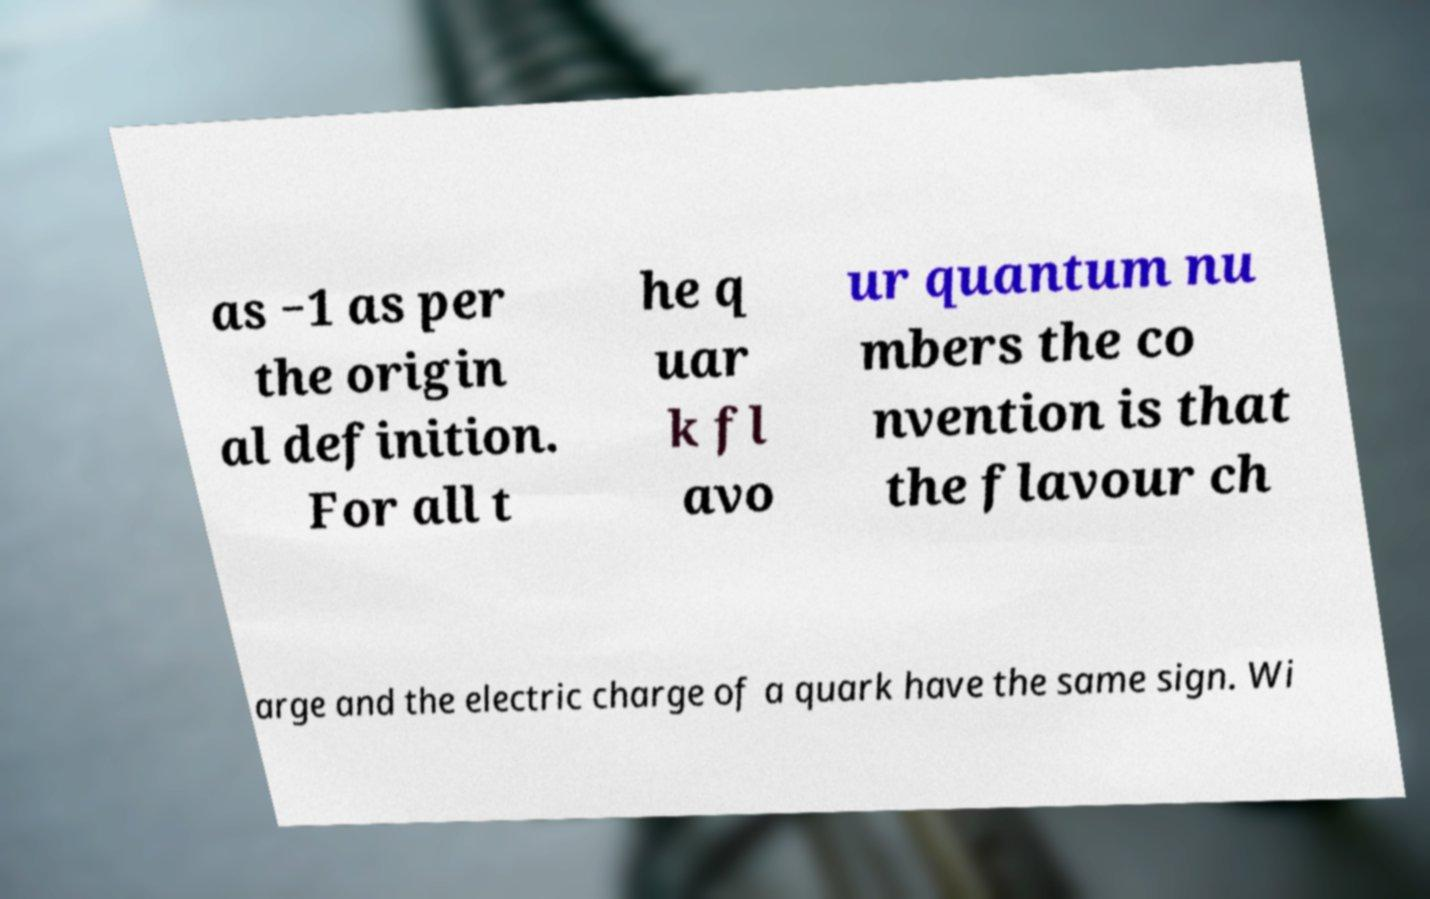For documentation purposes, I need the text within this image transcribed. Could you provide that? as −1 as per the origin al definition. For all t he q uar k fl avo ur quantum nu mbers the co nvention is that the flavour ch arge and the electric charge of a quark have the same sign. Wi 